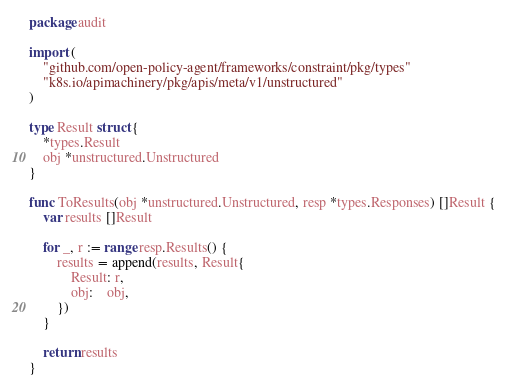<code> <loc_0><loc_0><loc_500><loc_500><_Go_>package audit

import (
	"github.com/open-policy-agent/frameworks/constraint/pkg/types"
	"k8s.io/apimachinery/pkg/apis/meta/v1/unstructured"
)

type Result struct {
	*types.Result
	obj *unstructured.Unstructured
}

func ToResults(obj *unstructured.Unstructured, resp *types.Responses) []Result {
	var results []Result

	for _, r := range resp.Results() {
		results = append(results, Result{
			Result: r,
			obj:    obj,
		})
	}

	return results
}
</code> 